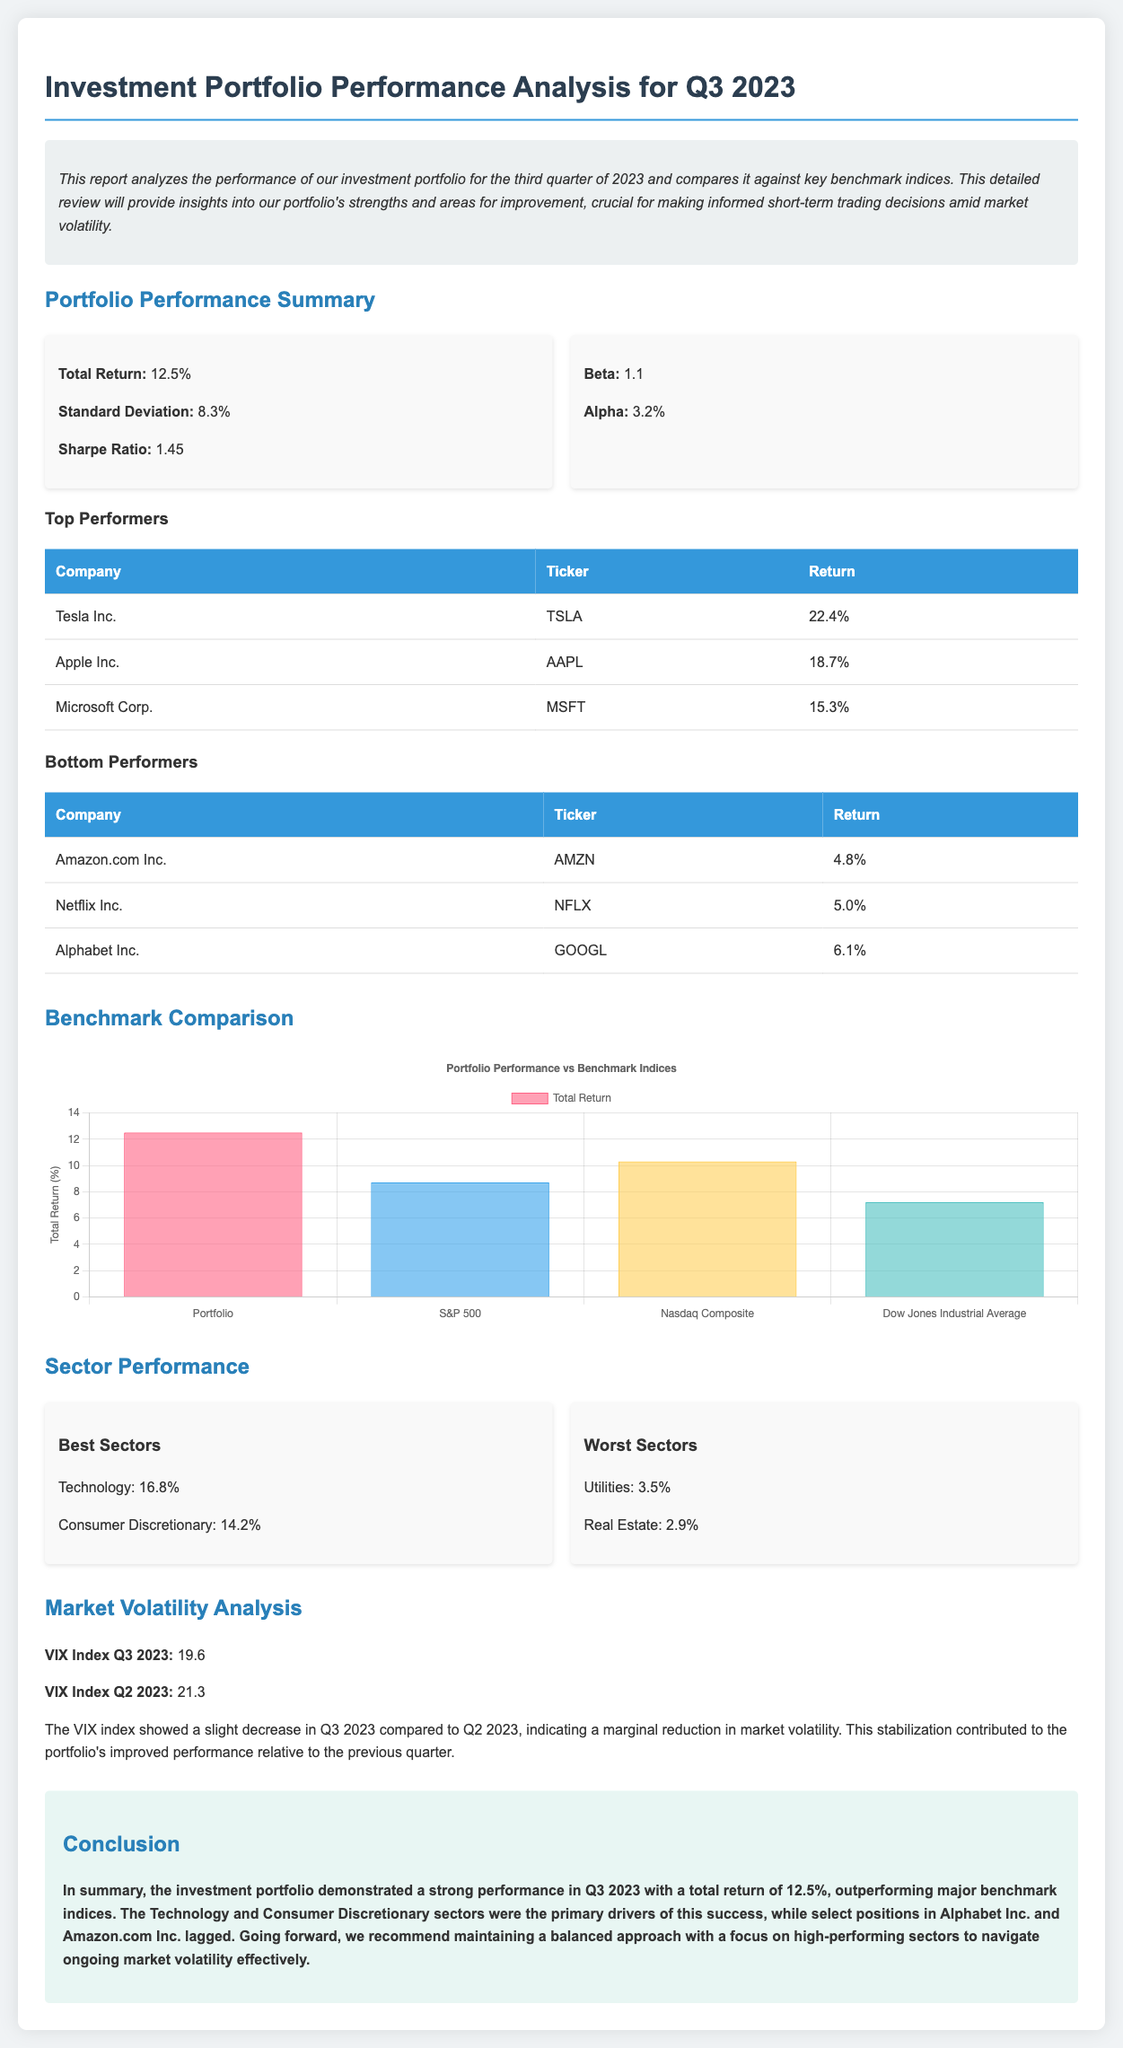What was the total return of the investment portfolio for Q3 2023? The total return is explicitly stated in the summary section of the document as 12.5%.
Answer: 12.5% What is the Sharpe Ratio of the investment portfolio? The Sharpe Ratio is one of the performance metrics provided in the summary, which is 1.45.
Answer: 1.45 Which company had the highest return in Q3 2023? The table of top performers lists Tesla Inc. with the highest return of 22.4%.
Answer: Tesla Inc What sector performed the best in Q3 2023? The performance grid identifies Technology as the best sector with a return of 16.8%.
Answer: Technology What was the VIX Index for Q2 2023? The document compares VIX Index values for Q3 and Q2 2023, indicating that the VIX Index for Q2 was 21.3.
Answer: 21.3 How does the portfolio's total return compare to the S&P 500? The benchmark comparison shows the portfolio's total return of 12.5% is significantly higher than the S&P 500's return of 8.7%.
Answer: Higher What was the beta of the investment portfolio? The beta, a measure of market risk, is mentioned in the summary as 1.1.
Answer: 1.1 Which two sectors were noted as the worst performers? The performance grid outlines Utilities and Real Estate as the worst-performing sectors due to their low returns of 3.5% and 2.9%.
Answer: Utilities, Real Estate What was the return of Alphabet Inc. for Q3 2023? The bottom performers table indicates a return of 6.1% for Alphabet Inc.
Answer: 6.1% 